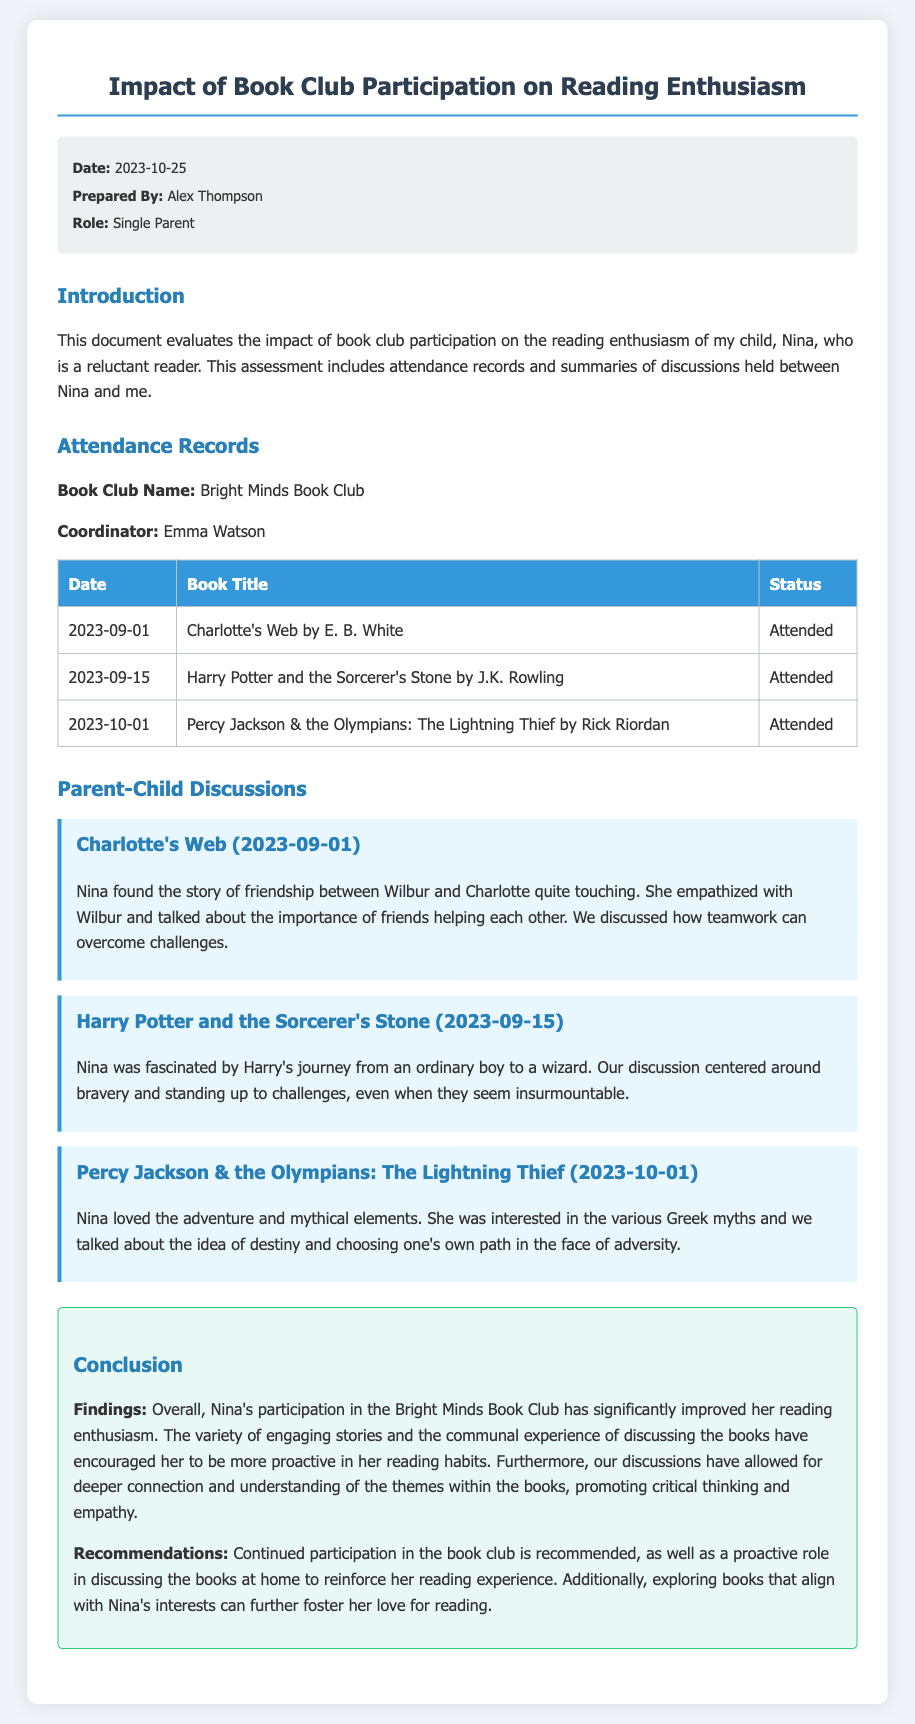what is the date of the appraisal document? The date of the appraisal document is specified in the meta-info section.
Answer: 2023-10-25 who prepared the document? The document indicates who prepared it in the meta-info section.
Answer: Alex Thompson what is the name of the book club? The book club is mentioned in the attendance records section.
Answer: Bright Minds Book Club how many books has Nina attended discussions for? The number of books can be counted from the attendance records table.
Answer: 3 what was the primary theme of the discussion for "Charlotte's Web"? The theme of the discussion is mentioned in the parent-child discussions section.
Answer: Friendship which book discusses the concept of bravery? The discussion summaries provide details on themes per book.
Answer: Harry Potter and the Sorcerer's Stone what general conclusion is drawn about Nina's reading enthusiasm? The conclusion section summarizes the overall impact of book club participation.
Answer: Improved what recommendation is made regarding Nina's participation in the book club? The recommendations are explicitly stated in the conclusion section.
Answer: Continued participation 